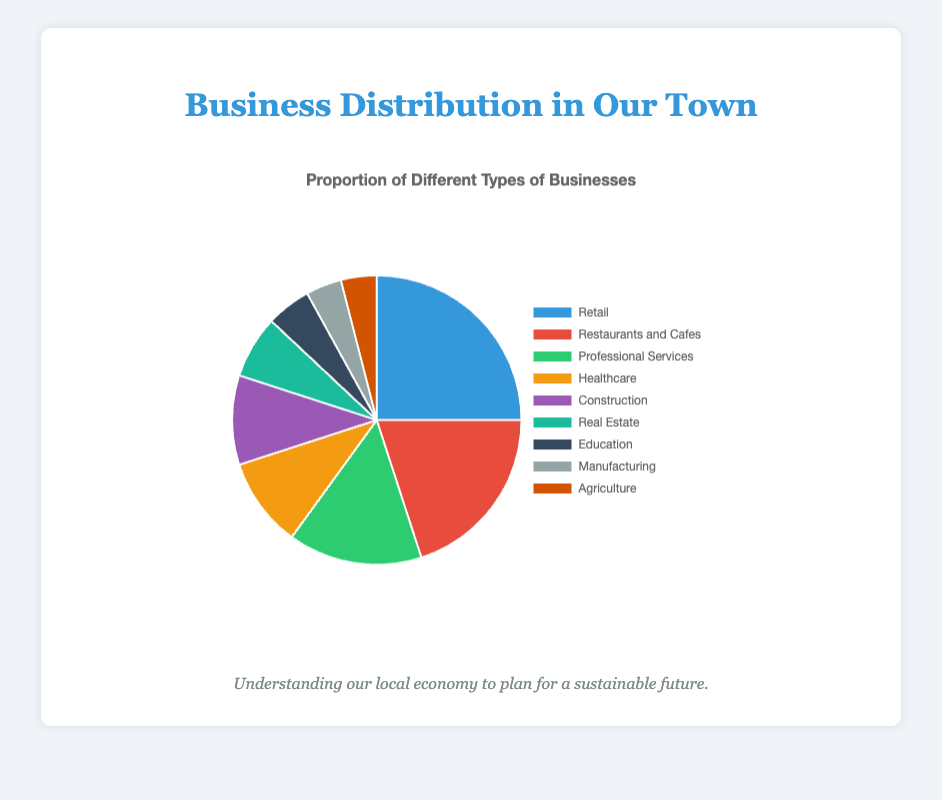What is the most common type of business in the town? The figure shows that Retail has the largest proportion, represented by the biggest slice.
Answer: Retail Which two types of businesses make up less than 5% of the town's economy each? From the pie chart, Manufacturing and Agriculture both have the smallest slices, each representing 4%.
Answer: Manufacturing and Agriculture What is the combined proportion of Professional Services and Healthcare? In the chart, Professional Services have a proportion of 15% and Healthcare has 10%. Adding these gives 15% + 10% = 25%.
Answer: 25% Which type of business has a larger proportion, Restaurants and Cafes or Construction? The chart shows that Restaurants and Cafes have a proportion of 20%, which is larger than Construction's 10%.
Answer: Restaurants and Cafes How many business types have a proportion greater than 10% each? In the chart, Retail (25%), Restaurants and Cafes (20%), and Professional Services (15%) each have proportions greater than 10%. So, three types meet this criterion.
Answer: 3 What is the difference in proportion between Real Estate and Education? The chart shows Real Estate at 7% and Education at 5%. The difference is 7% - 5% = 2%.
Answer: 2% Which section of the pie chart is represented in green? According to the figure's color coding, green corresponds to Professional Services, which has a proportion of 15%.
Answer: Professional Services If the proportions of Education and Agriculture were combined, would they equal the proportion of Healthcare? The chart shows Education at 5% and Agriculture at 4%. Their combined proportion is 5% + 4% = 9%, which is less than Healthcare’s 10%.
Answer: No What is the average proportion of the four largest business types? The four largest slices are Retail (25%), Restaurants and Cafes (20%), Professional Services (15%), and Healthcare (10%). The average is (25% + 20% + 15% + 10%) / 4 = 70% / 4 = 17.5%.
Answer: 17.5% Which type of business has the smallest proportion in the town's economy? From the pie chart, both Manufacturing and Agriculture have the smallest slices, each representing 4%.
Answer: Manufacturing and Agriculture 